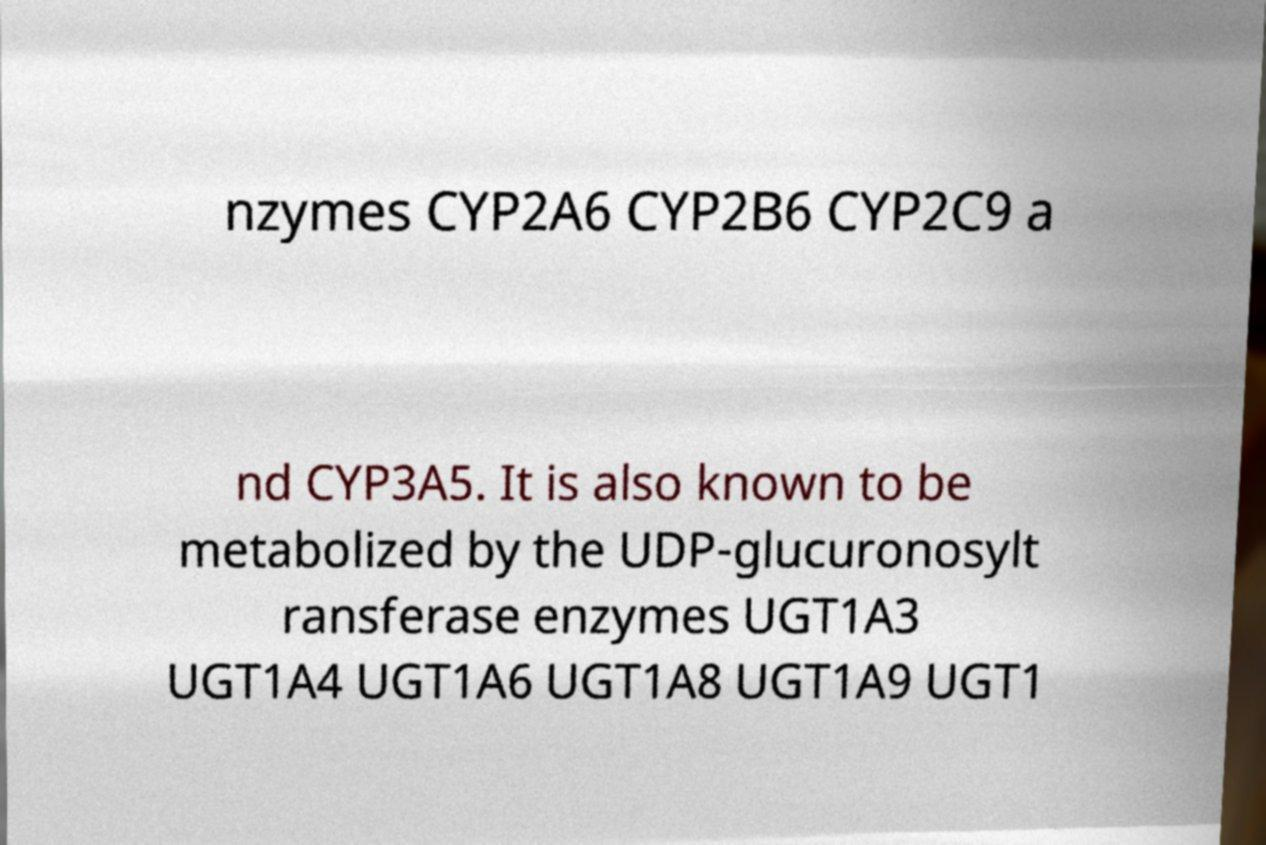There's text embedded in this image that I need extracted. Can you transcribe it verbatim? nzymes CYP2A6 CYP2B6 CYP2C9 a nd CYP3A5. It is also known to be metabolized by the UDP-glucuronosylt ransferase enzymes UGT1A3 UGT1A4 UGT1A6 UGT1A8 UGT1A9 UGT1 